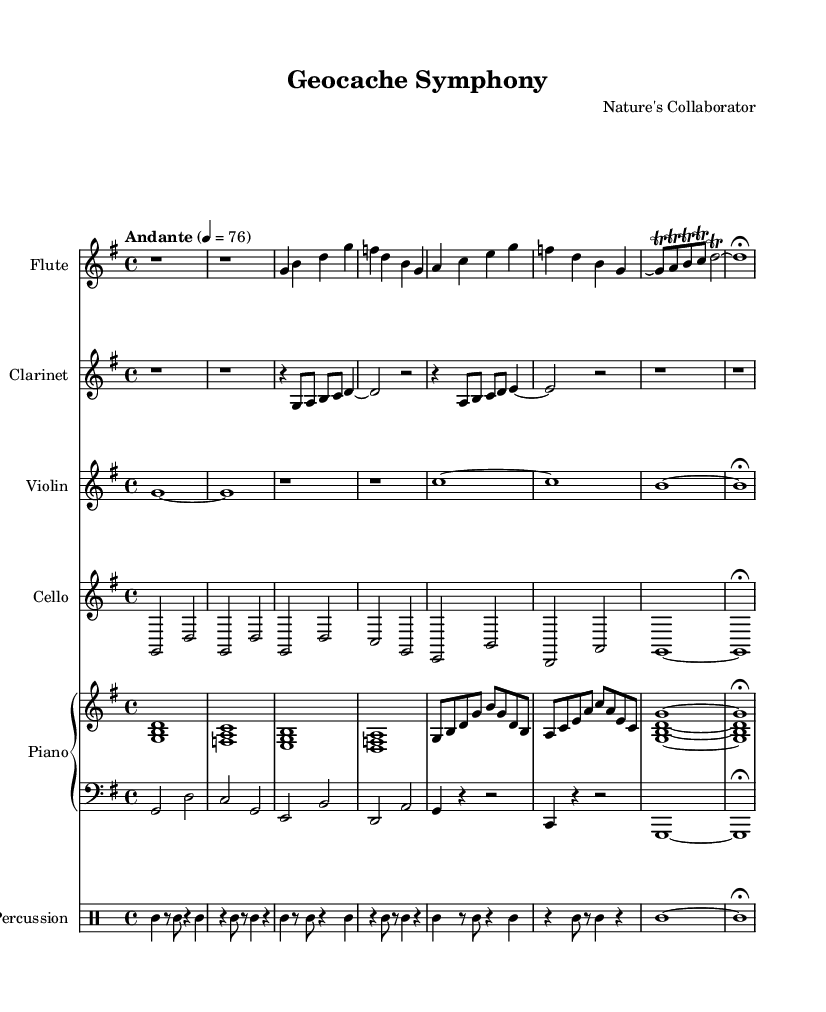What is the key signature of this music? The key signature indicates that there is one sharp, which means it is in G major. The G major scale consists of the notes G, A, B, C, D, E, and F#.
Answer: G major What is the time signature of this music? The time signature shown at the beginning of the score is 4/4, which indicates that there are four beats in each measure and the quarter note gets one beat.
Answer: 4/4 What is the tempo marking for this piece? The tempo marking at the beginning indicates "Andante," which commonly means a moderate tempo, specifically around 76 beats per minute in this context.
Answer: Andante How many measures are present in the flute part? By counting the vertical lines that separate the music into sections, we can determine that there are 9 measures in the flute part.
Answer: 9 Which instruments are included in the score? The score contains Flute, Clarinet, Violin, Cello, Piano (with right and left staves), and Percussion. These instruments are indicated by their respective staff names.
Answer: Flute, Clarinet, Violin, Cello, Piano, Percussion How many voices are present in the piano part? The piano part is divided into two staves: one for the right hand and one for the left hand, thus indicating two voices in the piano part.
Answer: 2 What type of notation is used for the trumpet part? There is no trumpet part present in this score; however, the instrument that is indicated with similar functions is the clarinet. Clarinet is noted on a separate staff, hence it serves the same role as a trumpet might in different compositions.
Answer: Clarinet 